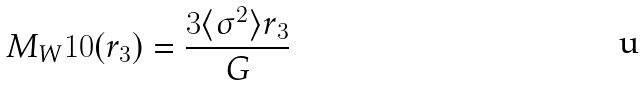Convert formula to latex. <formula><loc_0><loc_0><loc_500><loc_500>M _ { W } 1 0 ( r _ { 3 } ) = \frac { 3 \langle \sigma ^ { 2 } \rangle r _ { 3 } } { G }</formula> 